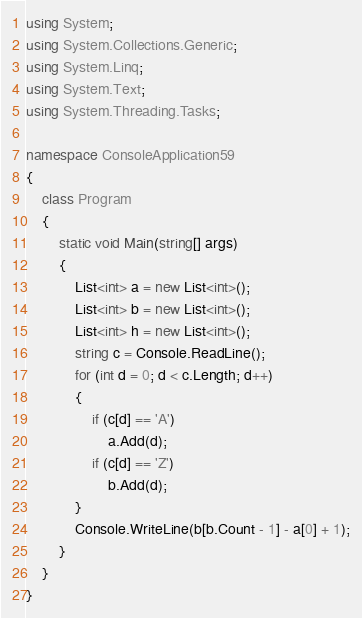<code> <loc_0><loc_0><loc_500><loc_500><_C#_>using System;
using System.Collections.Generic;
using System.Linq;
using System.Text;
using System.Threading.Tasks;

namespace ConsoleApplication59
{
    class Program
    {
        static void Main(string[] args)
        {
            List<int> a = new List<int>();
            List<int> b = new List<int>();
            List<int> h = new List<int>();
            string c = Console.ReadLine();
            for (int d = 0; d < c.Length; d++)
            {
                if (c[d] == 'A')
                    a.Add(d);
                if (c[d] == 'Z')
                    b.Add(d);
            }
            Console.WriteLine(b[b.Count - 1] - a[0] + 1);
        }
    }
}
</code> 